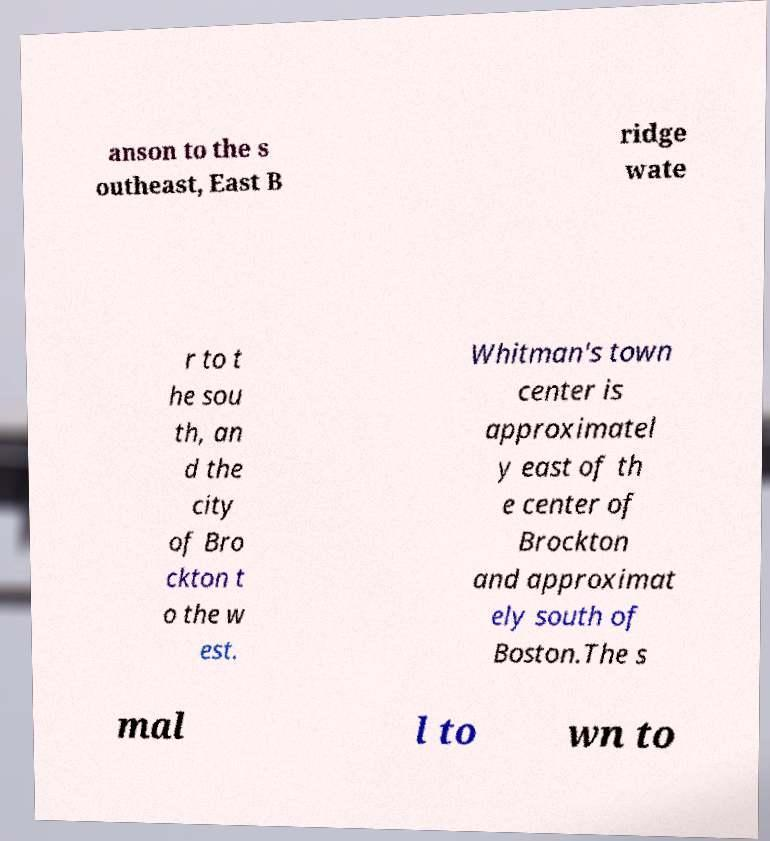For documentation purposes, I need the text within this image transcribed. Could you provide that? anson to the s outheast, East B ridge wate r to t he sou th, an d the city of Bro ckton t o the w est. Whitman's town center is approximatel y east of th e center of Brockton and approximat ely south of Boston.The s mal l to wn to 